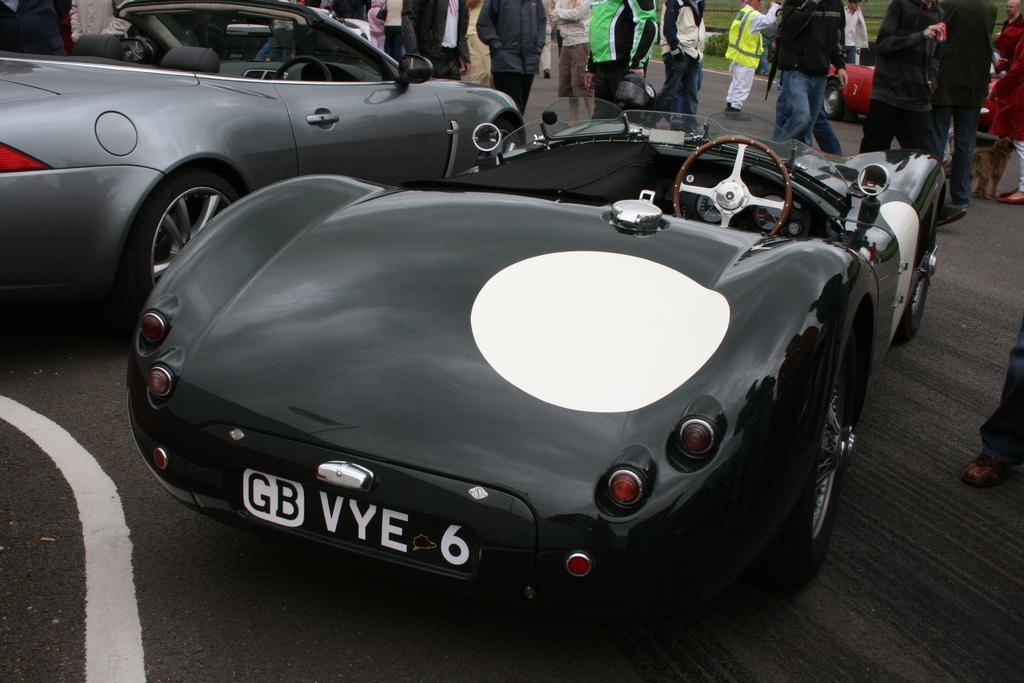Describe this image in one or two sentences. In this image, we can see two cars and there are some people standing. 